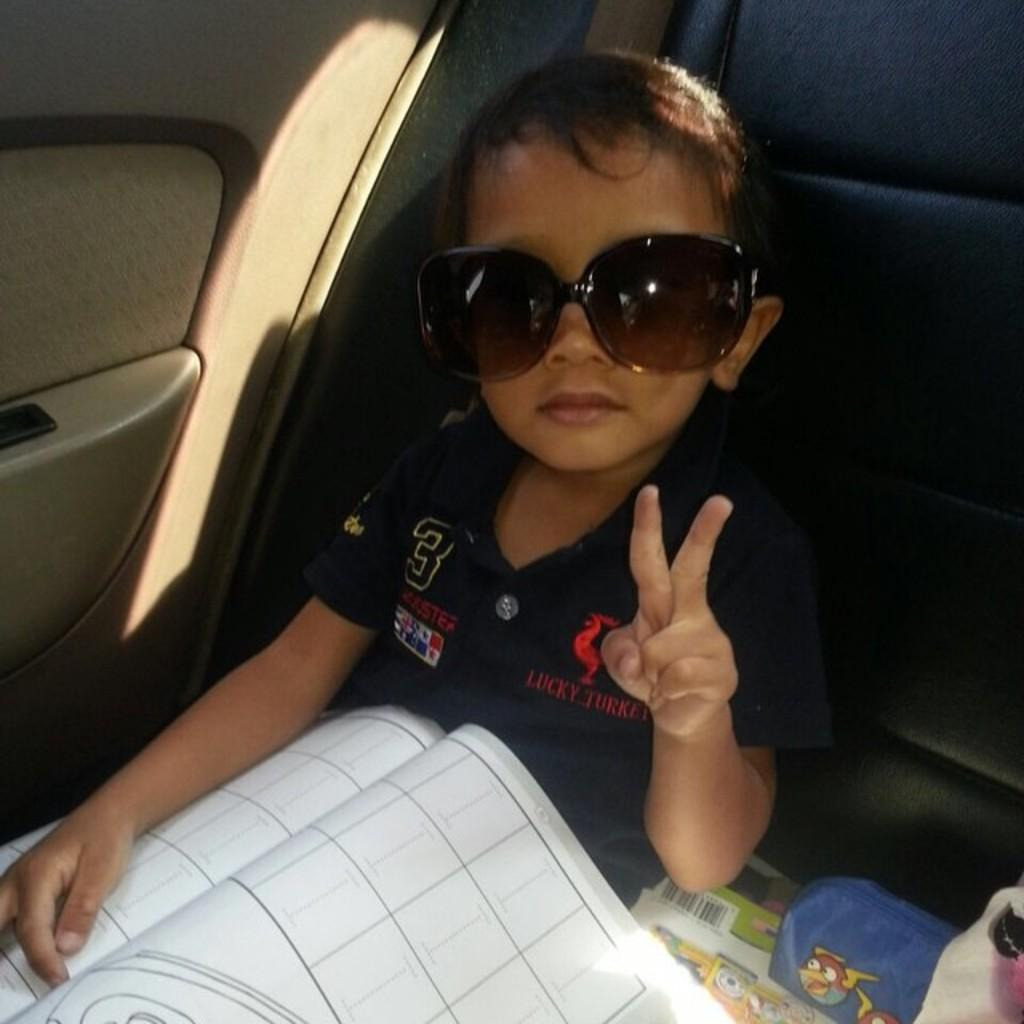Who is the main subject in the image? There is a boy in the image. What is the boy doing in the image? The boy is sitting in the seat of a vehicle. What is the boy holding or interacting with in the image? The boy has a book in his lap. What accessory is the boy wearing in the image? The boy is wearing spectacles. What type of quilt is covering the boy in the image? There is no quilt present in the image; the boy is wearing spectacles and sitting in a vehicle with a book in his lap. 